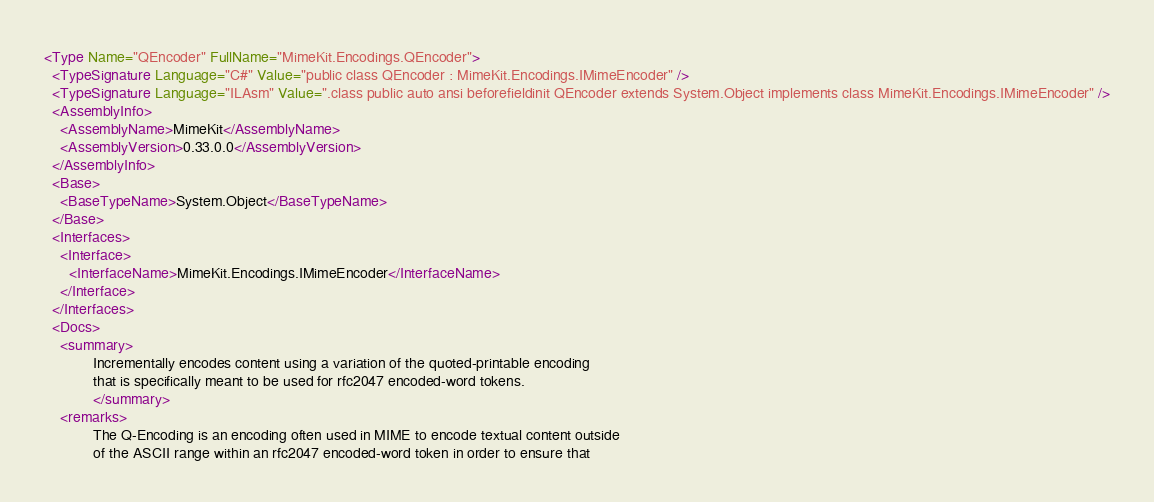Convert code to text. <code><loc_0><loc_0><loc_500><loc_500><_XML_><Type Name="QEncoder" FullName="MimeKit.Encodings.QEncoder">
  <TypeSignature Language="C#" Value="public class QEncoder : MimeKit.Encodings.IMimeEncoder" />
  <TypeSignature Language="ILAsm" Value=".class public auto ansi beforefieldinit QEncoder extends System.Object implements class MimeKit.Encodings.IMimeEncoder" />
  <AssemblyInfo>
    <AssemblyName>MimeKit</AssemblyName>
    <AssemblyVersion>0.33.0.0</AssemblyVersion>
  </AssemblyInfo>
  <Base>
    <BaseTypeName>System.Object</BaseTypeName>
  </Base>
  <Interfaces>
    <Interface>
      <InterfaceName>MimeKit.Encodings.IMimeEncoder</InterfaceName>
    </Interface>
  </Interfaces>
  <Docs>
    <summary>
            Incrementally encodes content using a variation of the quoted-printable encoding
            that is specifically meant to be used for rfc2047 encoded-word tokens.
            </summary>
    <remarks>
            The Q-Encoding is an encoding often used in MIME to encode textual content outside
            of the ASCII range within an rfc2047 encoded-word token in order to ensure that</code> 